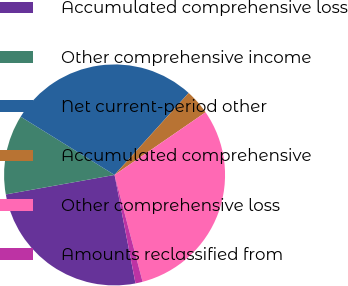Convert chart to OTSL. <chart><loc_0><loc_0><loc_500><loc_500><pie_chart><fcel>Accumulated comprehensive loss<fcel>Other comprehensive income<fcel>Net current-period other<fcel>Accumulated comprehensive<fcel>Other comprehensive loss<fcel>Amounts reclassified from<nl><fcel>25.21%<fcel>11.66%<fcel>27.86%<fcel>3.71%<fcel>30.51%<fcel>1.05%<nl></chart> 